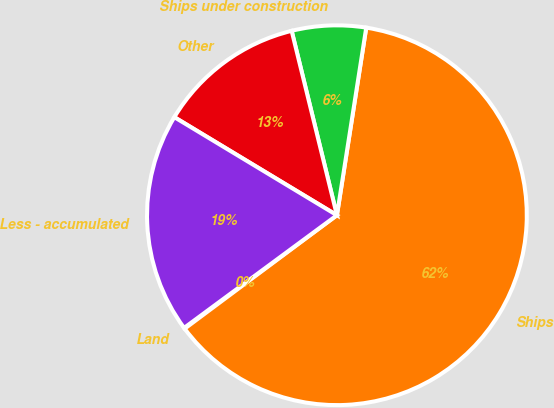Convert chart to OTSL. <chart><loc_0><loc_0><loc_500><loc_500><pie_chart><fcel>Land<fcel>Ships<fcel>Ships under construction<fcel>Other<fcel>Less - accumulated<nl><fcel>0.08%<fcel>62.34%<fcel>6.3%<fcel>12.53%<fcel>18.75%<nl></chart> 